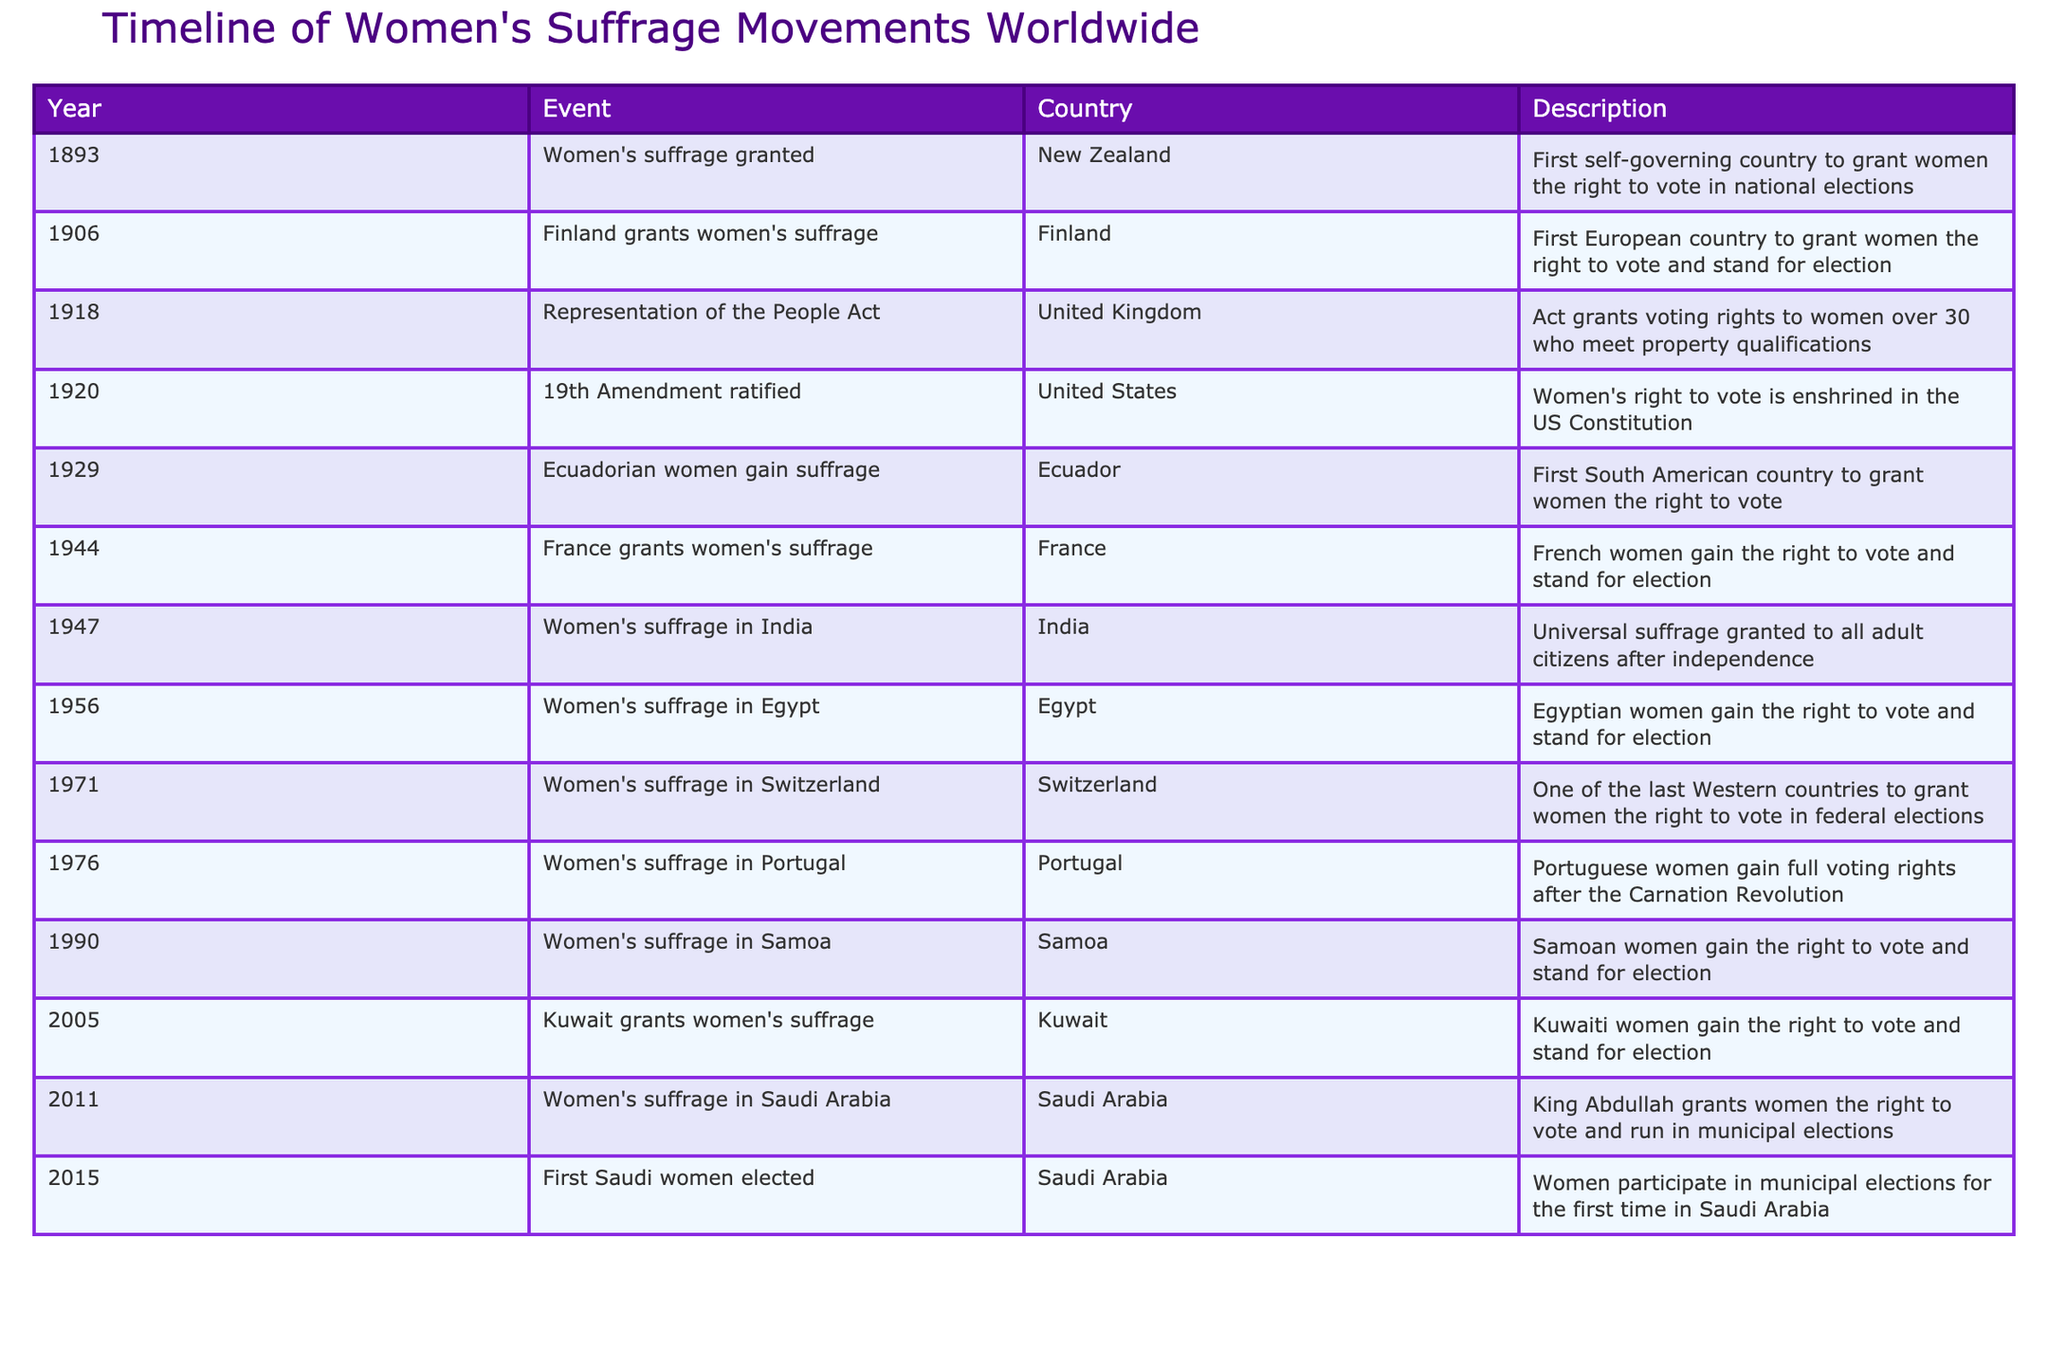What year did New Zealand grant women's suffrage? New Zealand granted women's suffrage in 1893, as stated in the table under the 'Year' column for that event.
Answer: 1893 Which country was the first in Europe to grant women's suffrage? According to the table, Finland was the first European country to grant women's suffrage in 1906.
Answer: Finland How many years passed between the first country granting women's suffrage and the ratification of the 19th Amendment in the United States? New Zealand granted women's suffrage in 1893, and the 19th Amendment was ratified in 1920. The difference in years is 1920 - 1893 = 27 years.
Answer: 27 years Did women in Saudi Arabia gain the right to vote before or after 2010? The table shows that women in Saudi Arabia gained the right to vote in 2011, which is after 2010. Therefore, the answer is no, they did not gain the right before 2010.
Answer: After How many countries gained women's suffrage in the 20th century according to the table? The table lists 11 countries that granted women's suffrage in the 20th century. By counting the entries under the 'Year' column from 1906 to 2005, we find those countries.
Answer: 11 countries Which event marks the first occurrence of women's suffrage in South America? The table shows that Ecuador granted women's suffrage in 1929, marking the first occurrence in South America, as indicated in the description.
Answer: Ecuador in 1929 What was the significant milestone for women in France regarding voting rights? The milestone for women in France was in 1944 when they were granted suffrage, as described in the event for that year.
Answer: 1944 Which two countries gained women's suffrage in the same decade, the 2000s? According to the table, both Kuwait (2005) and Saudi Arabia (2011) gained women's suffrage in the 2000s. However, only Kuwait falls within the decade itself while Saudi Arabia is in the next decade. Thus, no two countries gained it in the same decade.
Answer: None in the same decade 